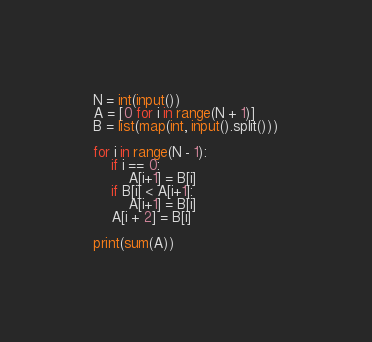Convert code to text. <code><loc_0><loc_0><loc_500><loc_500><_Python_>N = int(input())
A = [0 for i in range(N + 1)]
B = list(map(int, input().split()))

for i in range(N - 1):
    if i == 0:
        A[i+1] = B[i]
    if B[i] < A[i+1]:
        A[i+1] = B[i]
    A[i + 2] = B[i]

print(sum(A))</code> 